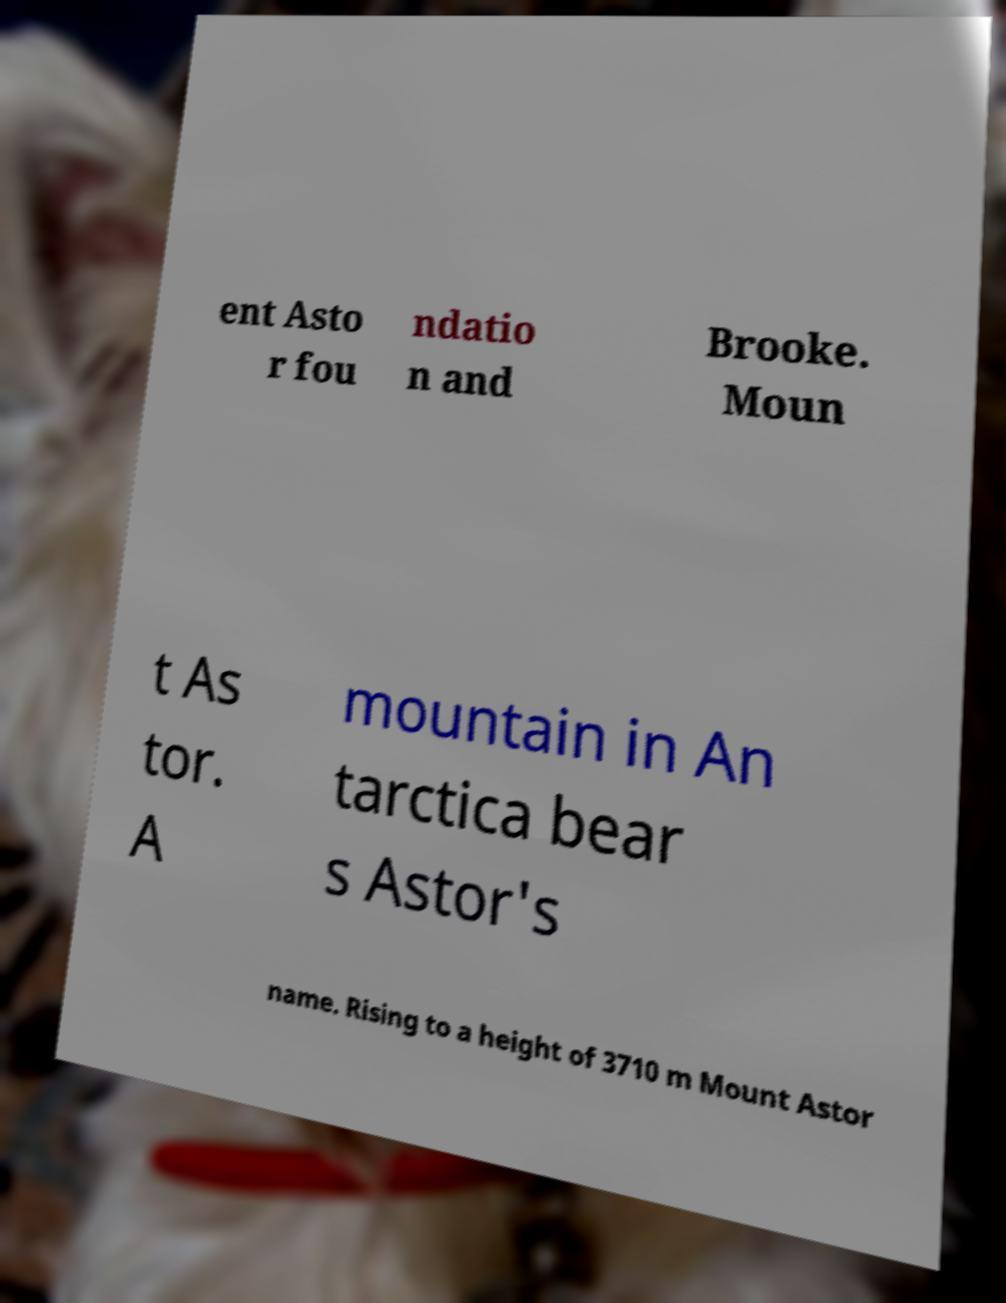Can you accurately transcribe the text from the provided image for me? ent Asto r fou ndatio n and Brooke. Moun t As tor. A mountain in An tarctica bear s Astor's name. Rising to a height of 3710 m Mount Astor 